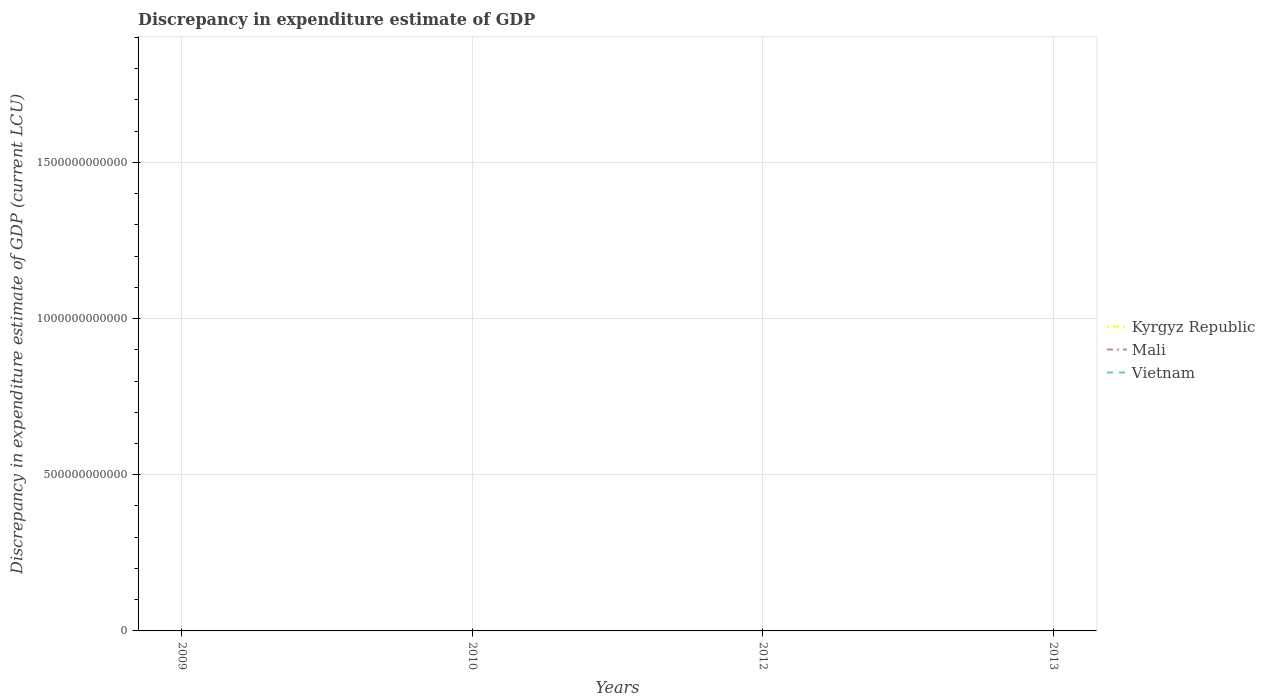How many different coloured lines are there?
Keep it short and to the point. 2. Does the line corresponding to Kyrgyz Republic intersect with the line corresponding to Mali?
Ensure brevity in your answer.  Yes. Is the number of lines equal to the number of legend labels?
Keep it short and to the point. No. What is the difference between the highest and the second highest discrepancy in expenditure estimate of GDP in Mali?
Keep it short and to the point. 0.01. What is the difference between the highest and the lowest discrepancy in expenditure estimate of GDP in Vietnam?
Provide a short and direct response. 0. How many lines are there?
Ensure brevity in your answer.  2. What is the difference between two consecutive major ticks on the Y-axis?
Your answer should be compact. 5.00e+11. Does the graph contain any zero values?
Offer a terse response. Yes. Does the graph contain grids?
Keep it short and to the point. Yes. How many legend labels are there?
Offer a very short reply. 3. What is the title of the graph?
Ensure brevity in your answer.  Discrepancy in expenditure estimate of GDP. What is the label or title of the Y-axis?
Ensure brevity in your answer.  Discrepancy in expenditure estimate of GDP (current LCU). What is the Discrepancy in expenditure estimate of GDP (current LCU) in Kyrgyz Republic in 2009?
Provide a succinct answer. 0. What is the Discrepancy in expenditure estimate of GDP (current LCU) in Mali in 2009?
Make the answer very short. 0. What is the Discrepancy in expenditure estimate of GDP (current LCU) of Kyrgyz Republic in 2010?
Offer a terse response. 2.800000000000001e-5. What is the Discrepancy in expenditure estimate of GDP (current LCU) in Mali in 2010?
Provide a short and direct response. 0.01. What is the Discrepancy in expenditure estimate of GDP (current LCU) in Vietnam in 2010?
Offer a very short reply. 0. What is the Discrepancy in expenditure estimate of GDP (current LCU) of Kyrgyz Republic in 2012?
Your answer should be very brief. 0. What is the Discrepancy in expenditure estimate of GDP (current LCU) in Kyrgyz Republic in 2013?
Offer a terse response. 8e-6. What is the Discrepancy in expenditure estimate of GDP (current LCU) of Mali in 2013?
Your answer should be very brief. 0. What is the Discrepancy in expenditure estimate of GDP (current LCU) in Vietnam in 2013?
Provide a short and direct response. 0. Across all years, what is the maximum Discrepancy in expenditure estimate of GDP (current LCU) of Kyrgyz Republic?
Provide a succinct answer. 2.800000000000001e-5. Across all years, what is the maximum Discrepancy in expenditure estimate of GDP (current LCU) in Mali?
Keep it short and to the point. 0.01. Across all years, what is the minimum Discrepancy in expenditure estimate of GDP (current LCU) of Kyrgyz Republic?
Give a very brief answer. 0. What is the total Discrepancy in expenditure estimate of GDP (current LCU) of Mali in the graph?
Your answer should be compact. 0.01. What is the average Discrepancy in expenditure estimate of GDP (current LCU) in Kyrgyz Republic per year?
Keep it short and to the point. 0. What is the average Discrepancy in expenditure estimate of GDP (current LCU) of Mali per year?
Provide a succinct answer. 0. What is the average Discrepancy in expenditure estimate of GDP (current LCU) of Vietnam per year?
Keep it short and to the point. 0. In the year 2010, what is the difference between the Discrepancy in expenditure estimate of GDP (current LCU) of Kyrgyz Republic and Discrepancy in expenditure estimate of GDP (current LCU) of Mali?
Offer a very short reply. -0.01. What is the difference between the highest and the lowest Discrepancy in expenditure estimate of GDP (current LCU) in Kyrgyz Republic?
Keep it short and to the point. 0. What is the difference between the highest and the lowest Discrepancy in expenditure estimate of GDP (current LCU) in Mali?
Make the answer very short. 0.01. 